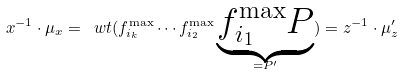Convert formula to latex. <formula><loc_0><loc_0><loc_500><loc_500>x ^ { - 1 } \cdot \mu _ { x } = \ w t ( f _ { i _ { k } } ^ { \max } \cdots f _ { i _ { 2 } } ^ { \max } \underbrace { f _ { i _ { 1 } } ^ { \max } P } _ { = P ^ { \prime } } ) = z ^ { - 1 } \cdot \mu ^ { \prime } _ { z }</formula> 